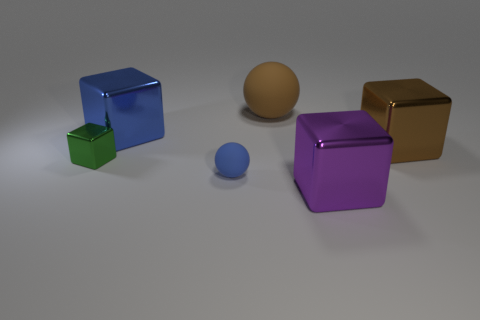There is a matte object to the right of the sphere that is in front of the big brown rubber ball; how many big metal cubes are left of it?
Make the answer very short. 1. How many metallic objects are small brown cylinders or purple blocks?
Ensure brevity in your answer.  1. There is a block that is behind the large thing on the right side of the purple thing; how big is it?
Offer a terse response. Large. There is a large block that is in front of the small shiny cube; is it the same color as the large ball that is behind the blue ball?
Provide a short and direct response. No. What color is the block that is in front of the large brown shiny block and to the left of the blue ball?
Your answer should be very brief. Green. Do the large sphere and the green object have the same material?
Your answer should be compact. No. What number of tiny things are either green blocks or blocks?
Keep it short and to the point. 1. Are there any other things that have the same shape as the large purple thing?
Ensure brevity in your answer.  Yes. Are there any other things that have the same size as the blue matte object?
Make the answer very short. Yes. There is a tiny object that is made of the same material as the large blue object; what is its color?
Your answer should be compact. Green. 